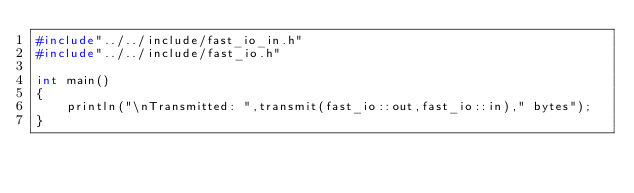Convert code to text. <code><loc_0><loc_0><loc_500><loc_500><_C++_>#include"../../include/fast_io_in.h"
#include"../../include/fast_io.h"

int main()
{
	println("\nTransmitted: ",transmit(fast_io::out,fast_io::in)," bytes");
}
</code> 